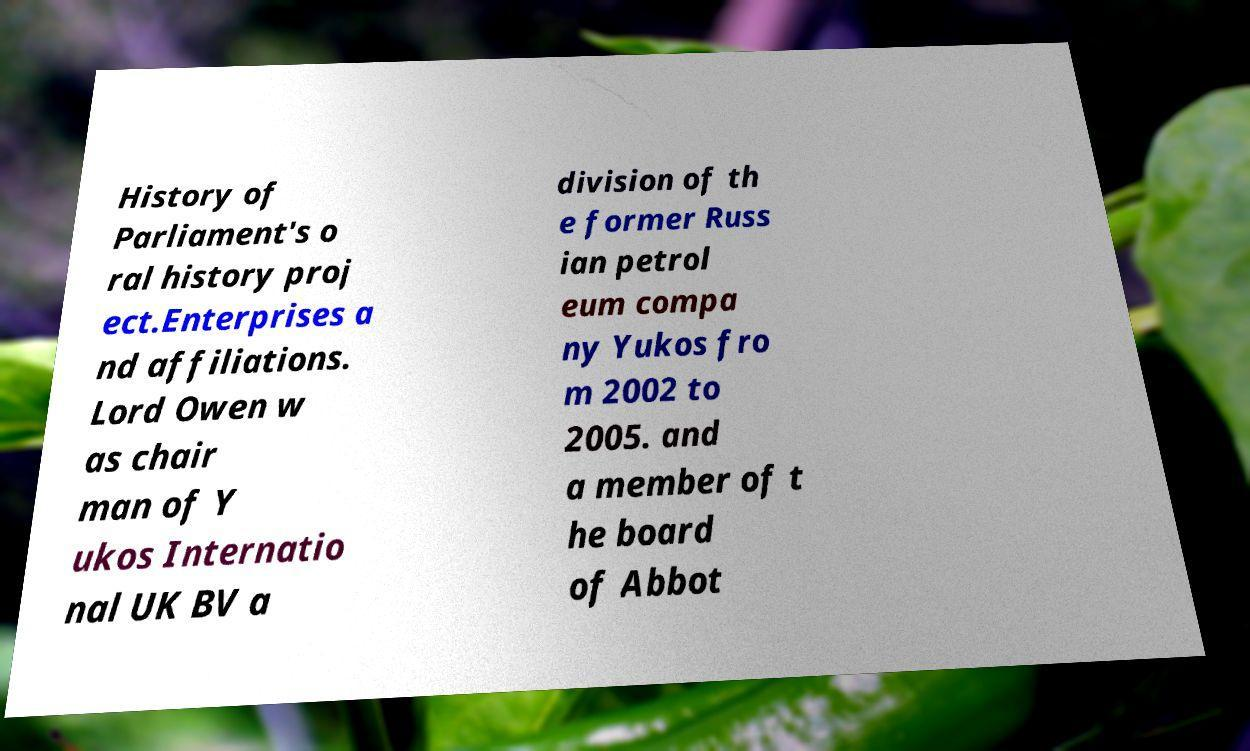Can you accurately transcribe the text from the provided image for me? History of Parliament's o ral history proj ect.Enterprises a nd affiliations. Lord Owen w as chair man of Y ukos Internatio nal UK BV a division of th e former Russ ian petrol eum compa ny Yukos fro m 2002 to 2005. and a member of t he board of Abbot 